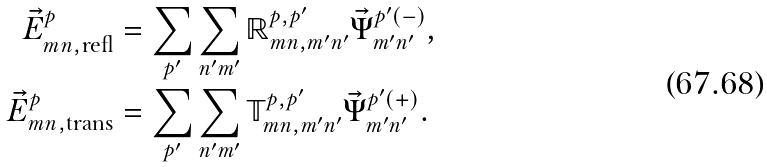<formula> <loc_0><loc_0><loc_500><loc_500>\vec { E } ^ { p } _ { m n , \text {refl} } & = \sum _ { p ^ { \prime } } \sum _ { n ^ { \prime } m ^ { \prime } } \mathbb { R } _ { m n , m ^ { \prime } n ^ { \prime } } ^ { p , p ^ { \prime } } \vec { \Psi } ^ { p ^ { \prime } ( - ) } _ { m ^ { \prime } n ^ { \prime } } , \\ \vec { E } ^ { p } _ { m n , \text {trans} } & = \sum _ { p ^ { \prime } } \sum _ { n ^ { \prime } m ^ { \prime } } \mathbb { T } _ { m n , m ^ { \prime } n ^ { \prime } } ^ { p , p ^ { \prime } } \vec { \Psi } ^ { p ^ { \prime } ( + ) } _ { m ^ { \prime } n ^ { \prime } } .</formula> 